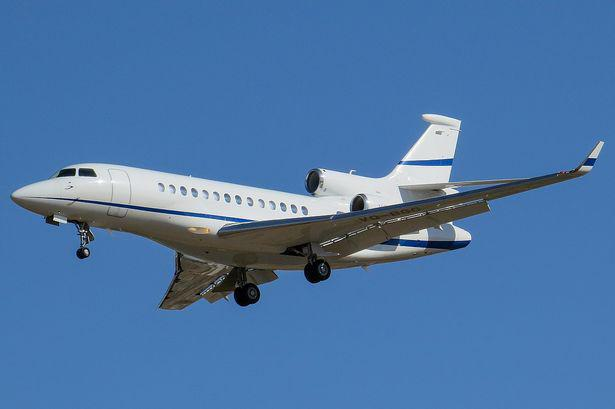Is there a aeroplane in the image? Yes, the image clearly features an airplane. It appears to be a business jet, possibly a model from the Dassault Falcon series, which is known for its high performance and luxury accommodations. The plane is depicted in flight against a clear blue sky, suggesting favorable weather conditions for flying. 